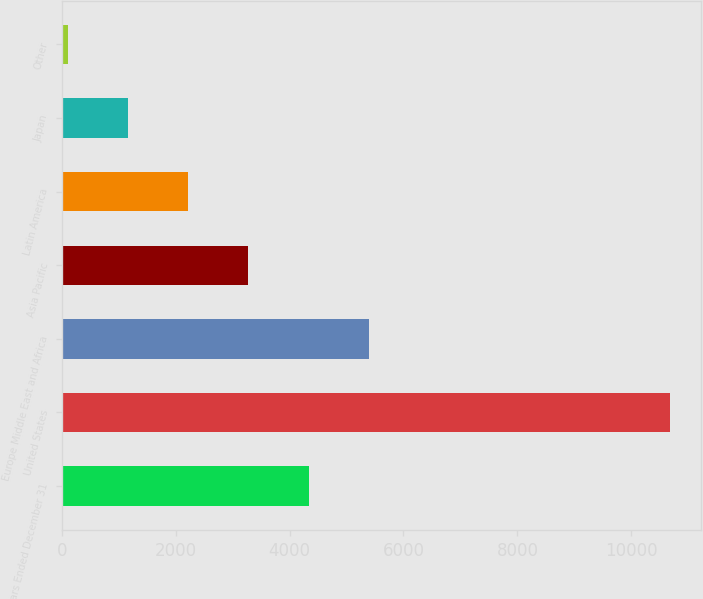<chart> <loc_0><loc_0><loc_500><loc_500><bar_chart><fcel>Years Ended December 31<fcel>United States<fcel>Europe Middle East and Africa<fcel>Asia Pacific<fcel>Latin America<fcel>Japan<fcel>Other<nl><fcel>4336.6<fcel>10687<fcel>5395<fcel>3278.2<fcel>2219.8<fcel>1161.4<fcel>103<nl></chart> 